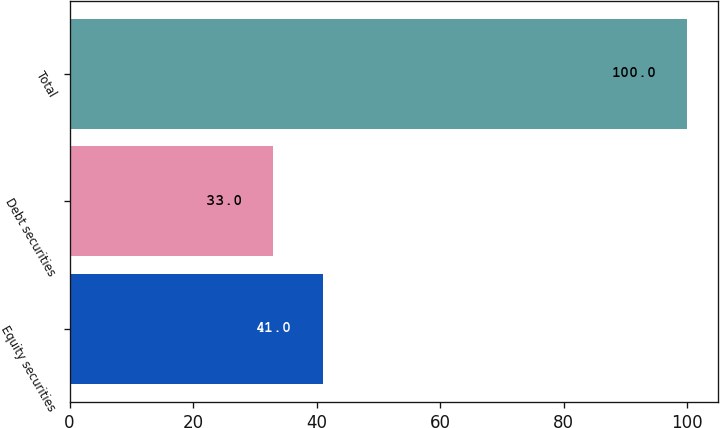Convert chart. <chart><loc_0><loc_0><loc_500><loc_500><bar_chart><fcel>Equity securities<fcel>Debt securities<fcel>Total<nl><fcel>41<fcel>33<fcel>100<nl></chart> 